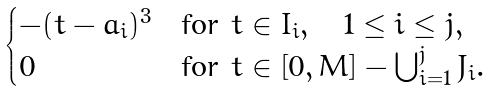<formula> <loc_0><loc_0><loc_500><loc_500>\begin{cases} - ( t - a _ { i } ) ^ { 3 } & \text {for } t \in I _ { i } , \quad 1 \leq i \leq j , \\ 0 & \text {for } t \in \left [ 0 , M \right ] - \bigcup _ { i = 1 } ^ { j } J _ { i } . \end{cases}</formula> 